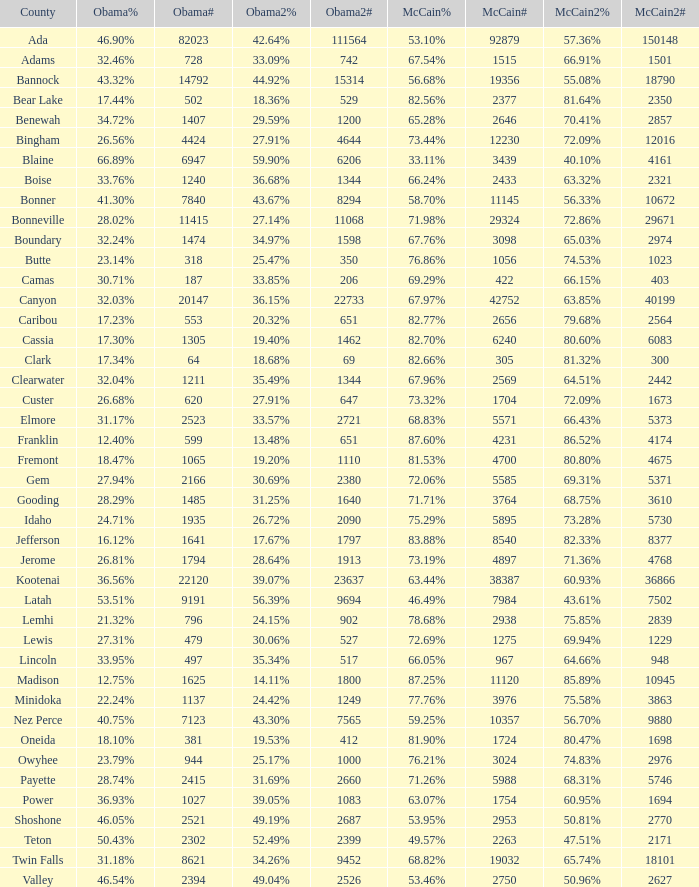What is the maximum McCain population turnout number? 92879.0. Help me parse the entirety of this table. {'header': ['County', 'Obama%', 'Obama#', 'Obama2%', 'Obama2#', 'McCain%', 'McCain#', 'McCain2%', 'McCain2#'], 'rows': [['Ada', '46.90%', '82023', '42.64%', '111564', '53.10%', '92879', '57.36%', '150148'], ['Adams', '32.46%', '728', '33.09%', '742', '67.54%', '1515', '66.91%', '1501'], ['Bannock', '43.32%', '14792', '44.92%', '15314', '56.68%', '19356', '55.08%', '18790'], ['Bear Lake', '17.44%', '502', '18.36%', '529', '82.56%', '2377', '81.64%', '2350'], ['Benewah', '34.72%', '1407', '29.59%', '1200', '65.28%', '2646', '70.41%', '2857'], ['Bingham', '26.56%', '4424', '27.91%', '4644', '73.44%', '12230', '72.09%', '12016'], ['Blaine', '66.89%', '6947', '59.90%', '6206', '33.11%', '3439', '40.10%', '4161'], ['Boise', '33.76%', '1240', '36.68%', '1344', '66.24%', '2433', '63.32%', '2321'], ['Bonner', '41.30%', '7840', '43.67%', '8294', '58.70%', '11145', '56.33%', '10672'], ['Bonneville', '28.02%', '11415', '27.14%', '11068', '71.98%', '29324', '72.86%', '29671'], ['Boundary', '32.24%', '1474', '34.97%', '1598', '67.76%', '3098', '65.03%', '2974'], ['Butte', '23.14%', '318', '25.47%', '350', '76.86%', '1056', '74.53%', '1023'], ['Camas', '30.71%', '187', '33.85%', '206', '69.29%', '422', '66.15%', '403'], ['Canyon', '32.03%', '20147', '36.15%', '22733', '67.97%', '42752', '63.85%', '40199'], ['Caribou', '17.23%', '553', '20.32%', '651', '82.77%', '2656', '79.68%', '2564'], ['Cassia', '17.30%', '1305', '19.40%', '1462', '82.70%', '6240', '80.60%', '6083'], ['Clark', '17.34%', '64', '18.68%', '69', '82.66%', '305', '81.32%', '300'], ['Clearwater', '32.04%', '1211', '35.49%', '1344', '67.96%', '2569', '64.51%', '2442'], ['Custer', '26.68%', '620', '27.91%', '647', '73.32%', '1704', '72.09%', '1673'], ['Elmore', '31.17%', '2523', '33.57%', '2721', '68.83%', '5571', '66.43%', '5373'], ['Franklin', '12.40%', '599', '13.48%', '651', '87.60%', '4231', '86.52%', '4174'], ['Fremont', '18.47%', '1065', '19.20%', '1110', '81.53%', '4700', '80.80%', '4675'], ['Gem', '27.94%', '2166', '30.69%', '2380', '72.06%', '5585', '69.31%', '5371'], ['Gooding', '28.29%', '1485', '31.25%', '1640', '71.71%', '3764', '68.75%', '3610'], ['Idaho', '24.71%', '1935', '26.72%', '2090', '75.29%', '5895', '73.28%', '5730'], ['Jefferson', '16.12%', '1641', '17.67%', '1797', '83.88%', '8540', '82.33%', '8377'], ['Jerome', '26.81%', '1794', '28.64%', '1913', '73.19%', '4897', '71.36%', '4768'], ['Kootenai', '36.56%', '22120', '39.07%', '23637', '63.44%', '38387', '60.93%', '36866'], ['Latah', '53.51%', '9191', '56.39%', '9694', '46.49%', '7984', '43.61%', '7502'], ['Lemhi', '21.32%', '796', '24.15%', '902', '78.68%', '2938', '75.85%', '2839'], ['Lewis', '27.31%', '479', '30.06%', '527', '72.69%', '1275', '69.94%', '1229'], ['Lincoln', '33.95%', '497', '35.34%', '517', '66.05%', '967', '64.66%', '948'], ['Madison', '12.75%', '1625', '14.11%', '1800', '87.25%', '11120', '85.89%', '10945'], ['Minidoka', '22.24%', '1137', '24.42%', '1249', '77.76%', '3976', '75.58%', '3863'], ['Nez Perce', '40.75%', '7123', '43.30%', '7565', '59.25%', '10357', '56.70%', '9880'], ['Oneida', '18.10%', '381', '19.53%', '412', '81.90%', '1724', '80.47%', '1698'], ['Owyhee', '23.79%', '944', '25.17%', '1000', '76.21%', '3024', '74.83%', '2976'], ['Payette', '28.74%', '2415', '31.69%', '2660', '71.26%', '5988', '68.31%', '5746'], ['Power', '36.93%', '1027', '39.05%', '1083', '63.07%', '1754', '60.95%', '1694'], ['Shoshone', '46.05%', '2521', '49.19%', '2687', '53.95%', '2953', '50.81%', '2770'], ['Teton', '50.43%', '2302', '52.49%', '2399', '49.57%', '2263', '47.51%', '2171'], ['Twin Falls', '31.18%', '8621', '34.26%', '9452', '68.82%', '19032', '65.74%', '18101'], ['Valley', '46.54%', '2394', '49.04%', '2526', '53.46%', '2750', '50.96%', '2627']]} 